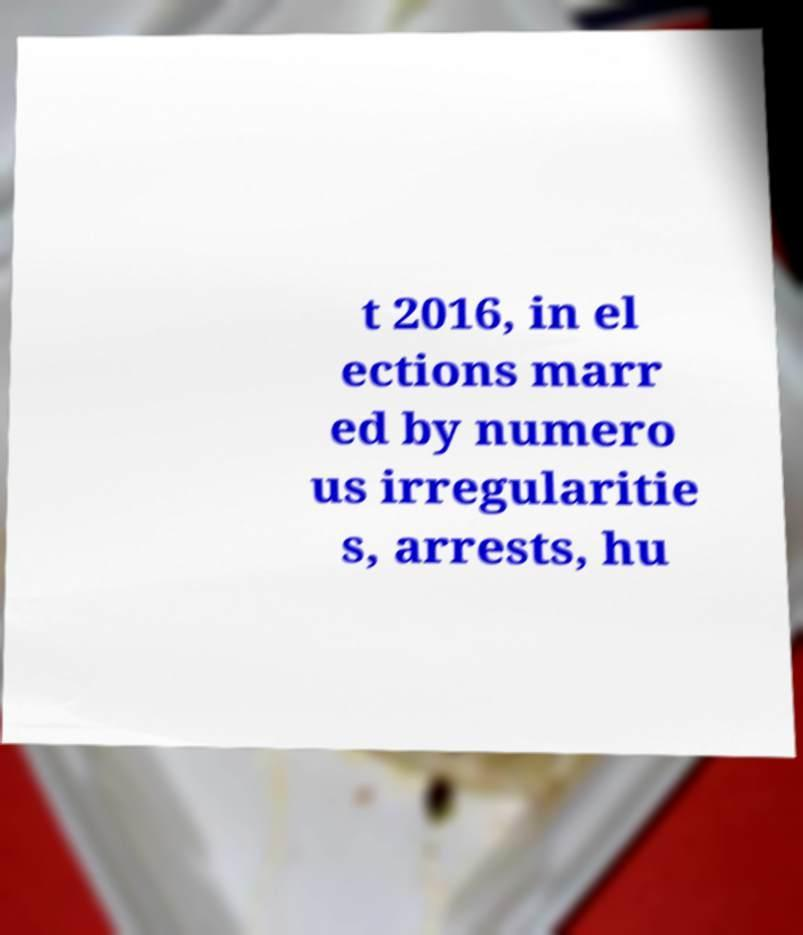What messages or text are displayed in this image? I need them in a readable, typed format. t 2016, in el ections marr ed by numero us irregularitie s, arrests, hu 